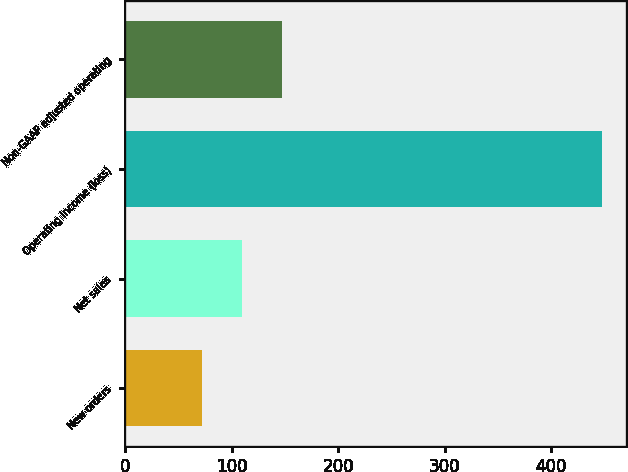Convert chart. <chart><loc_0><loc_0><loc_500><loc_500><bar_chart><fcel>New orders<fcel>Net sales<fcel>Operating income (loss)<fcel>Non-GAAP adjusted operating<nl><fcel>72<fcel>109.6<fcel>448<fcel>147.2<nl></chart> 